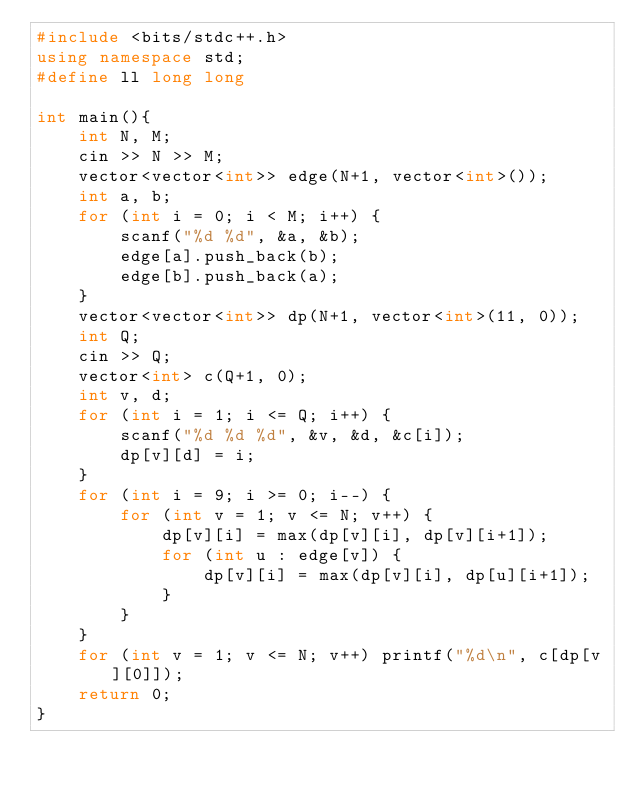<code> <loc_0><loc_0><loc_500><loc_500><_C++_>#include <bits/stdc++.h>
using namespace std;
#define ll long long

int main(){
    int N, M;
    cin >> N >> M;
    vector<vector<int>> edge(N+1, vector<int>());
    int a, b;
    for (int i = 0; i < M; i++) {
        scanf("%d %d", &a, &b);
        edge[a].push_back(b);
        edge[b].push_back(a);
    }
    vector<vector<int>> dp(N+1, vector<int>(11, 0));
    int Q;
    cin >> Q;
    vector<int> c(Q+1, 0);
    int v, d;
    for (int i = 1; i <= Q; i++) {
        scanf("%d %d %d", &v, &d, &c[i]);
        dp[v][d] = i;
    }
    for (int i = 9; i >= 0; i--) {
        for (int v = 1; v <= N; v++) {
            dp[v][i] = max(dp[v][i], dp[v][i+1]);
            for (int u : edge[v]) {
                dp[v][i] = max(dp[v][i], dp[u][i+1]);
            }
        }
    }
    for (int v = 1; v <= N; v++) printf("%d\n", c[dp[v][0]]);
    return 0;
}
</code> 